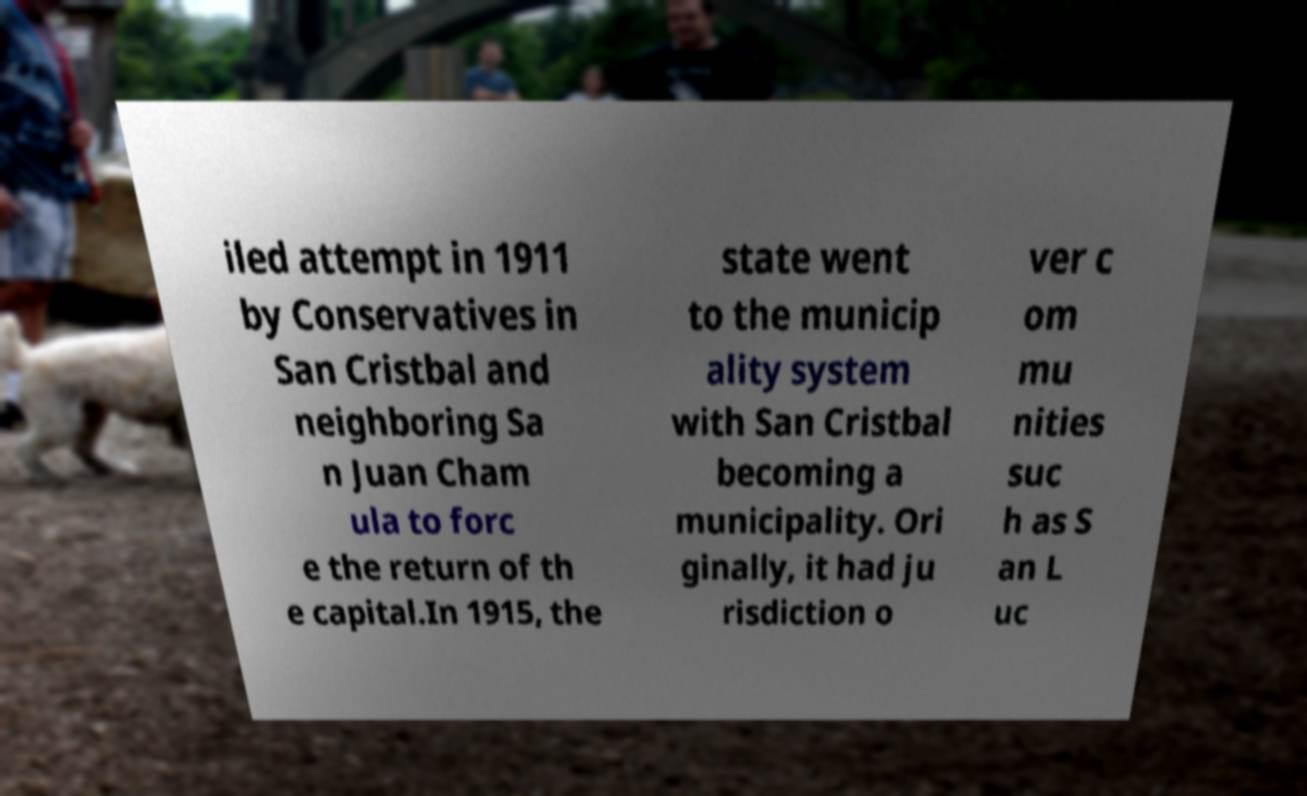Please identify and transcribe the text found in this image. iled attempt in 1911 by Conservatives in San Cristbal and neighboring Sa n Juan Cham ula to forc e the return of th e capital.In 1915, the state went to the municip ality system with San Cristbal becoming a municipality. Ori ginally, it had ju risdiction o ver c om mu nities suc h as S an L uc 